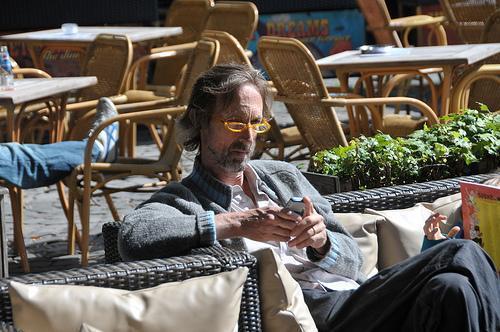What is the man wearing?
Choose the right answer from the provided options to respond to the question.
Options: Crown, glasses, backpack, hat. Glasses. 